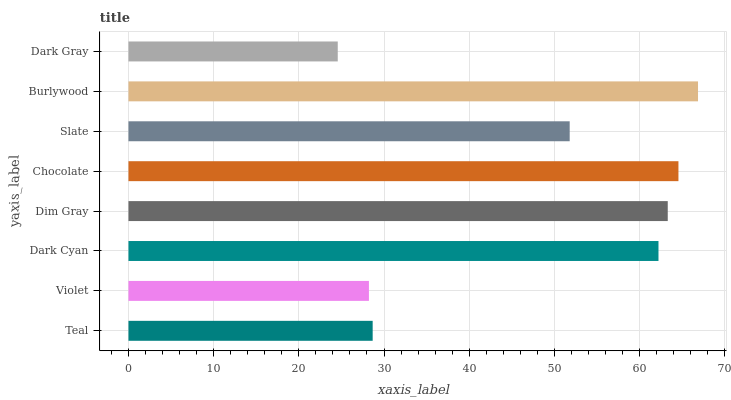Is Dark Gray the minimum?
Answer yes or no. Yes. Is Burlywood the maximum?
Answer yes or no. Yes. Is Violet the minimum?
Answer yes or no. No. Is Violet the maximum?
Answer yes or no. No. Is Teal greater than Violet?
Answer yes or no. Yes. Is Violet less than Teal?
Answer yes or no. Yes. Is Violet greater than Teal?
Answer yes or no. No. Is Teal less than Violet?
Answer yes or no. No. Is Dark Cyan the high median?
Answer yes or no. Yes. Is Slate the low median?
Answer yes or no. Yes. Is Slate the high median?
Answer yes or no. No. Is Dark Cyan the low median?
Answer yes or no. No. 